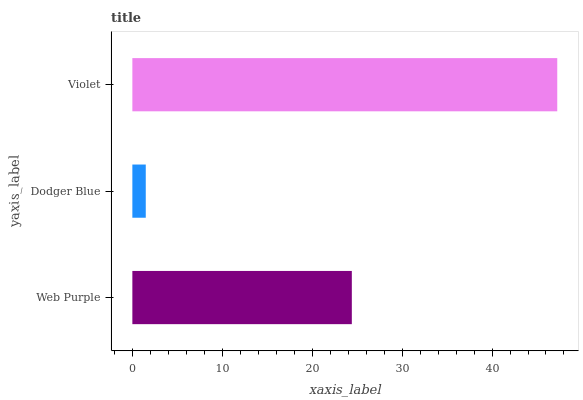Is Dodger Blue the minimum?
Answer yes or no. Yes. Is Violet the maximum?
Answer yes or no. Yes. Is Violet the minimum?
Answer yes or no. No. Is Dodger Blue the maximum?
Answer yes or no. No. Is Violet greater than Dodger Blue?
Answer yes or no. Yes. Is Dodger Blue less than Violet?
Answer yes or no. Yes. Is Dodger Blue greater than Violet?
Answer yes or no. No. Is Violet less than Dodger Blue?
Answer yes or no. No. Is Web Purple the high median?
Answer yes or no. Yes. Is Web Purple the low median?
Answer yes or no. Yes. Is Violet the high median?
Answer yes or no. No. Is Violet the low median?
Answer yes or no. No. 